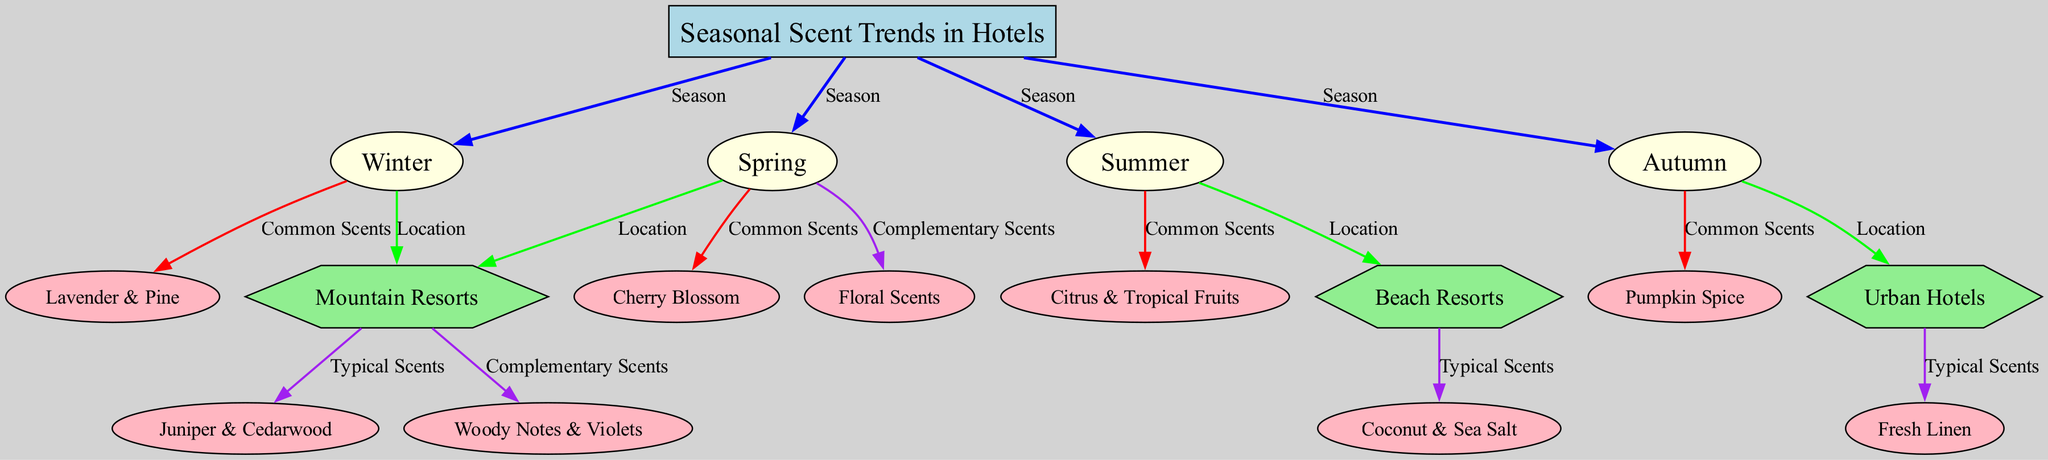what are the common scents in winter? The diagram shows that the common scents associated with the winter season are "Lavender & Pine." This information is found through the edge that connects the winter node (2) to the common scents node (9).
Answer: Lavender & Pine how many seasonal nodes are represented in the diagram? The diagram contains four seasonal nodes: winter, spring, summer, and autumn. These can be counted from the labels attached to the respective nodes (2, 3, 4, and 5).
Answer: 4 what scents are typical for beach resorts? The diagram indicates that the typical scents for beach resorts are "Coconut & Sea Salt." This is derived from the connection between the beach resorts node (7) and the typical scents (14) node.
Answer: Coconut & Sea Salt which location is associated with autumn scents? The autumn scent relationship described in the diagram connects to urban hotels. The edge leading from the autumn node (5) to the urban hotels node (8) confirms this association.
Answer: Urban Hotels what are the complementary scents in spring? In the diagram, it shows that the complementary scents related to spring are "Floral Scents." This is evident from the edge connecting the spring node (3) to floral scents node (17).
Answer: Floral Scents how many edges connect seasonal to location nodes? There are seven edges that connect the seasonal nodes (2, 3, 4, 5) to the location nodes (6, 7, 8) in the diagram. Each seasonal node connects specifically to one or more location nodes as seen from the connections outlined.
Answer: 7 what scents are common in summer hotels? According to the diagram, the common scents for summer are "Citrus & Tropical Fruits." This information is acquired by following the edge connecting the summer season node (4) to common scents (11) node.
Answer: Citrus & Tropical Fruits what complementary scent is linked to mountain resorts? The diagram indicates that the complementary scent linked to mountain resorts is "Woody Notes & Violets." This conclusion comes from the diagram showing the connection from mountain resorts node (6) to complementary scents node (16).
Answer: Woody Notes & Violets which seasonal node has the highest number of connections? The seasonal node spring has the highest number of connections with two arrows pointing out, connecting it to a location (mountain resorts) and common scents (cherry blossom). This is compared against the other seasonal nodes, which have fewer connections.
Answer: Spring 